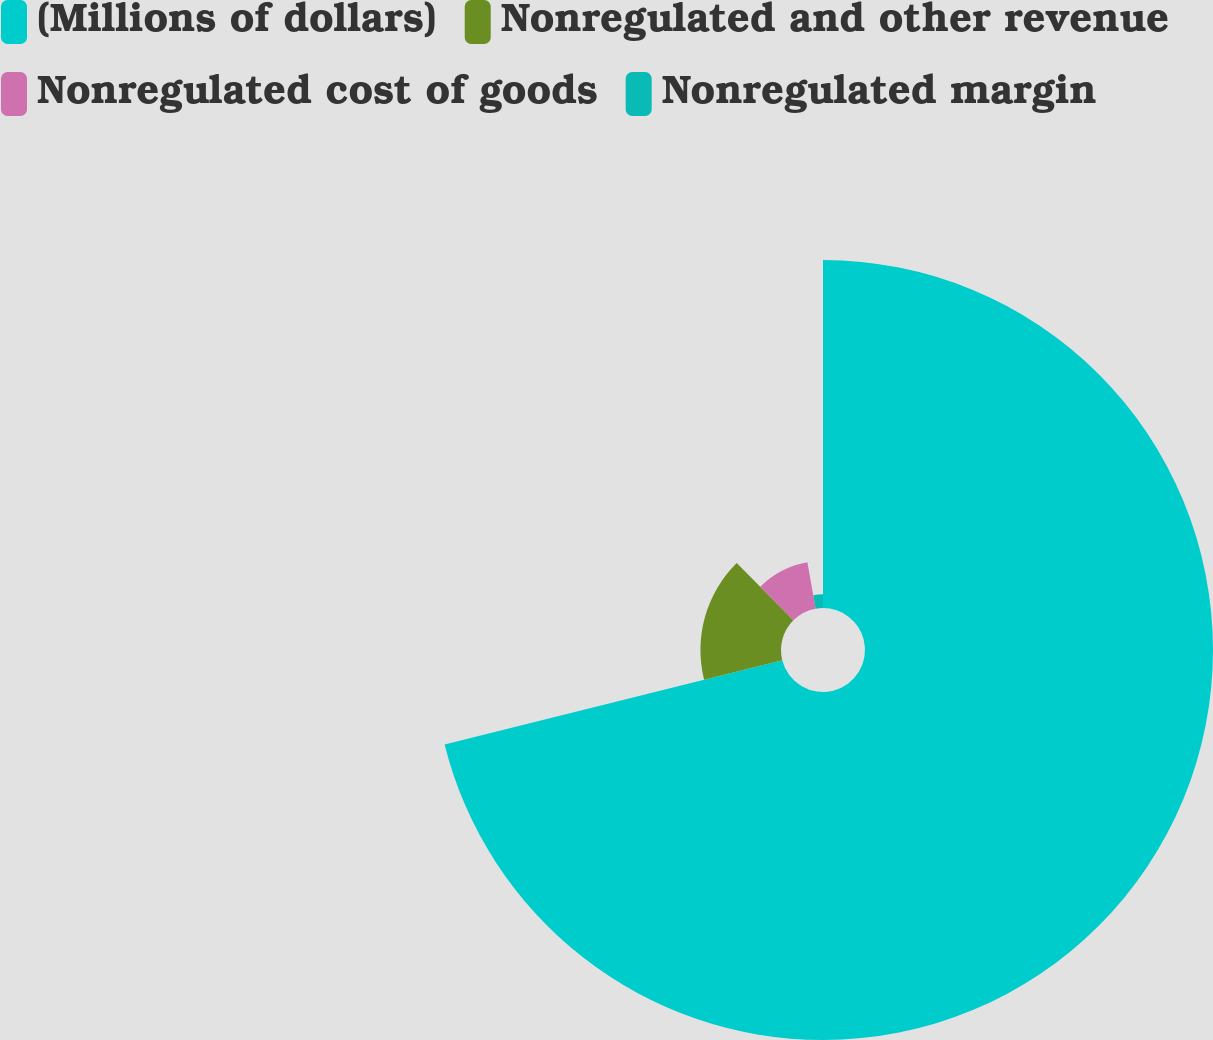Convert chart. <chart><loc_0><loc_0><loc_500><loc_500><pie_chart><fcel>(Millions of dollars)<fcel>Nonregulated and other revenue<fcel>Nonregulated cost of goods<fcel>Nonregulated margin<nl><fcel>71.1%<fcel>16.46%<fcel>9.63%<fcel>2.8%<nl></chart> 